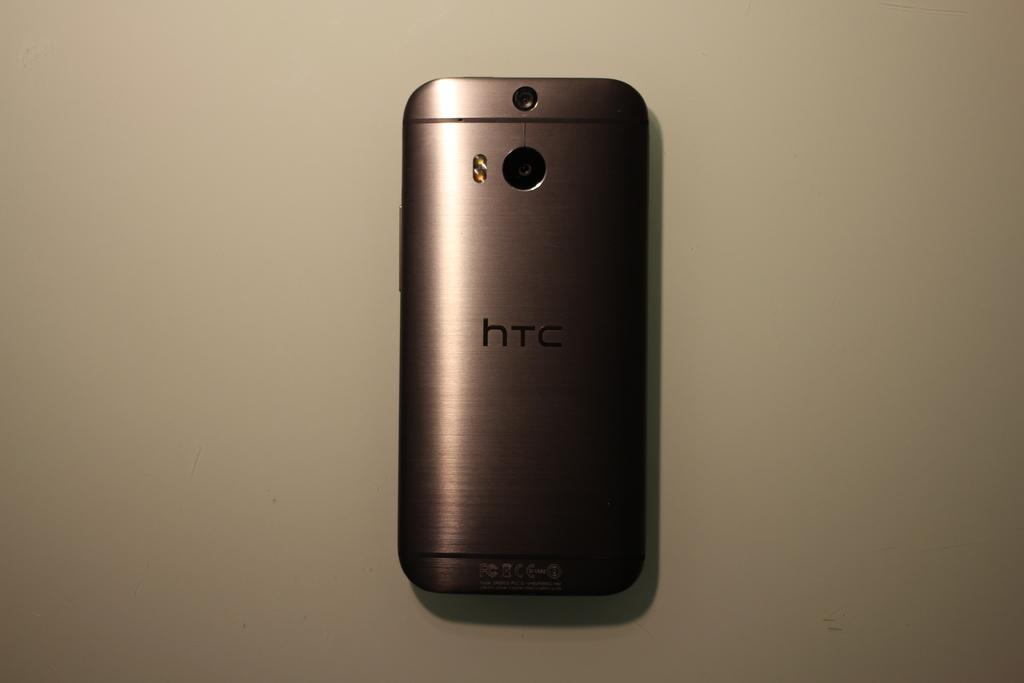Provide a one-sentence caption for the provided image. A black smarthpone with HTC written on the back lays face down. 